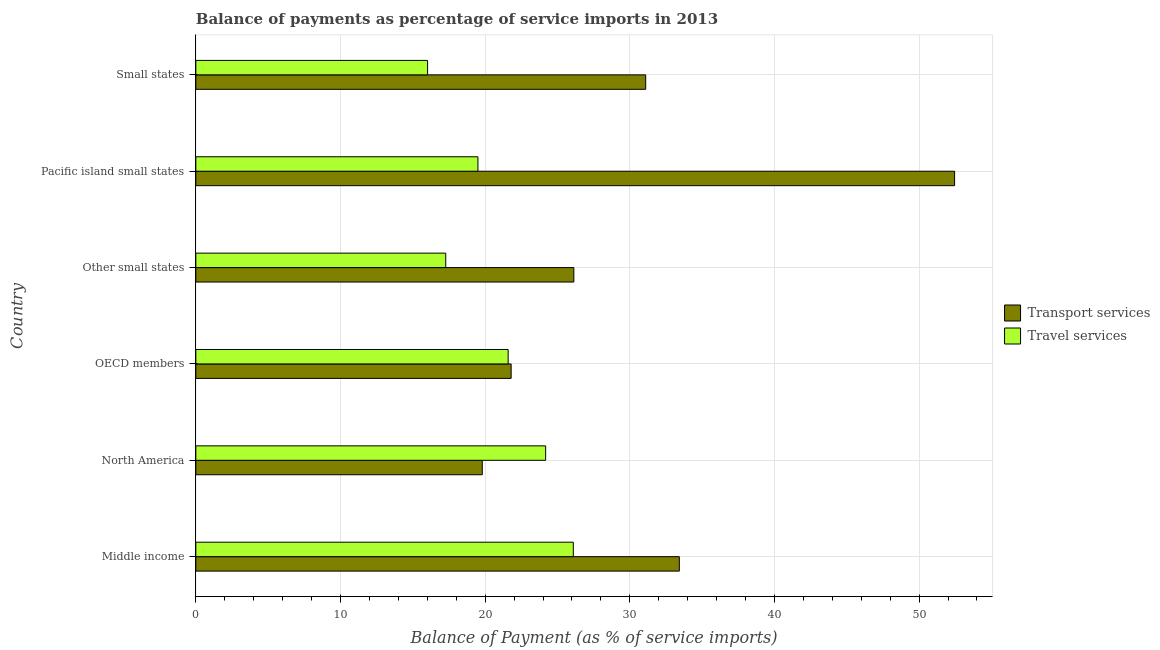How many different coloured bars are there?
Your answer should be compact. 2. How many groups of bars are there?
Your response must be concise. 6. Are the number of bars per tick equal to the number of legend labels?
Your answer should be very brief. Yes. Are the number of bars on each tick of the Y-axis equal?
Provide a succinct answer. Yes. How many bars are there on the 1st tick from the bottom?
Offer a terse response. 2. What is the label of the 3rd group of bars from the top?
Keep it short and to the point. Other small states. In how many cases, is the number of bars for a given country not equal to the number of legend labels?
Provide a succinct answer. 0. What is the balance of payments of travel services in Middle income?
Your answer should be very brief. 26.1. Across all countries, what is the maximum balance of payments of travel services?
Your answer should be very brief. 26.1. Across all countries, what is the minimum balance of payments of travel services?
Your answer should be very brief. 16.02. In which country was the balance of payments of transport services maximum?
Your response must be concise. Pacific island small states. In which country was the balance of payments of travel services minimum?
Make the answer very short. Small states. What is the total balance of payments of transport services in the graph?
Offer a very short reply. 184.71. What is the difference between the balance of payments of travel services in OECD members and that in Small states?
Keep it short and to the point. 5.57. What is the difference between the balance of payments of travel services in Middle income and the balance of payments of transport services in Other small states?
Your answer should be compact. -0.04. What is the average balance of payments of travel services per country?
Offer a terse response. 20.78. What is the difference between the balance of payments of transport services and balance of payments of travel services in Middle income?
Give a very brief answer. 7.33. In how many countries, is the balance of payments of travel services greater than 36 %?
Offer a terse response. 0. What is the ratio of the balance of payments of travel services in North America to that in Pacific island small states?
Make the answer very short. 1.24. Is the balance of payments of transport services in OECD members less than that in Pacific island small states?
Your answer should be compact. Yes. Is the difference between the balance of payments of travel services in OECD members and Small states greater than the difference between the balance of payments of transport services in OECD members and Small states?
Make the answer very short. Yes. What is the difference between the highest and the second highest balance of payments of travel services?
Your answer should be compact. 1.91. What is the difference between the highest and the lowest balance of payments of transport services?
Provide a short and direct response. 32.65. In how many countries, is the balance of payments of transport services greater than the average balance of payments of transport services taken over all countries?
Give a very brief answer. 3. Is the sum of the balance of payments of transport services in Middle income and Small states greater than the maximum balance of payments of travel services across all countries?
Ensure brevity in your answer.  Yes. What does the 2nd bar from the top in North America represents?
Ensure brevity in your answer.  Transport services. What does the 1st bar from the bottom in Small states represents?
Offer a terse response. Transport services. How many bars are there?
Offer a terse response. 12. Are the values on the major ticks of X-axis written in scientific E-notation?
Ensure brevity in your answer.  No. Does the graph contain any zero values?
Ensure brevity in your answer.  No. Does the graph contain grids?
Your answer should be very brief. Yes. Where does the legend appear in the graph?
Make the answer very short. Center right. How many legend labels are there?
Your answer should be compact. 2. What is the title of the graph?
Your answer should be compact. Balance of payments as percentage of service imports in 2013. What is the label or title of the X-axis?
Provide a succinct answer. Balance of Payment (as % of service imports). What is the Balance of Payment (as % of service imports) of Transport services in Middle income?
Offer a very short reply. 33.42. What is the Balance of Payment (as % of service imports) in Travel services in Middle income?
Your answer should be compact. 26.1. What is the Balance of Payment (as % of service imports) in Transport services in North America?
Offer a terse response. 19.8. What is the Balance of Payment (as % of service imports) in Travel services in North America?
Give a very brief answer. 24.18. What is the Balance of Payment (as % of service imports) of Transport services in OECD members?
Provide a short and direct response. 21.8. What is the Balance of Payment (as % of service imports) in Travel services in OECD members?
Provide a succinct answer. 21.59. What is the Balance of Payment (as % of service imports) in Transport services in Other small states?
Provide a short and direct response. 26.13. What is the Balance of Payment (as % of service imports) in Travel services in Other small states?
Provide a short and direct response. 17.28. What is the Balance of Payment (as % of service imports) of Transport services in Pacific island small states?
Make the answer very short. 52.45. What is the Balance of Payment (as % of service imports) of Travel services in Pacific island small states?
Offer a terse response. 19.5. What is the Balance of Payment (as % of service imports) in Transport services in Small states?
Keep it short and to the point. 31.1. What is the Balance of Payment (as % of service imports) of Travel services in Small states?
Offer a very short reply. 16.02. Across all countries, what is the maximum Balance of Payment (as % of service imports) in Transport services?
Ensure brevity in your answer.  52.45. Across all countries, what is the maximum Balance of Payment (as % of service imports) in Travel services?
Ensure brevity in your answer.  26.1. Across all countries, what is the minimum Balance of Payment (as % of service imports) of Transport services?
Offer a very short reply. 19.8. Across all countries, what is the minimum Balance of Payment (as % of service imports) in Travel services?
Offer a very short reply. 16.02. What is the total Balance of Payment (as % of service imports) of Transport services in the graph?
Offer a terse response. 184.71. What is the total Balance of Payment (as % of service imports) of Travel services in the graph?
Keep it short and to the point. 124.67. What is the difference between the Balance of Payment (as % of service imports) in Transport services in Middle income and that in North America?
Give a very brief answer. 13.62. What is the difference between the Balance of Payment (as % of service imports) of Travel services in Middle income and that in North America?
Your answer should be very brief. 1.91. What is the difference between the Balance of Payment (as % of service imports) of Transport services in Middle income and that in OECD members?
Offer a very short reply. 11.63. What is the difference between the Balance of Payment (as % of service imports) in Travel services in Middle income and that in OECD members?
Make the answer very short. 4.5. What is the difference between the Balance of Payment (as % of service imports) in Transport services in Middle income and that in Other small states?
Offer a very short reply. 7.29. What is the difference between the Balance of Payment (as % of service imports) of Travel services in Middle income and that in Other small states?
Offer a very short reply. 8.82. What is the difference between the Balance of Payment (as % of service imports) of Transport services in Middle income and that in Pacific island small states?
Offer a very short reply. -19.03. What is the difference between the Balance of Payment (as % of service imports) in Travel services in Middle income and that in Pacific island small states?
Provide a succinct answer. 6.59. What is the difference between the Balance of Payment (as % of service imports) of Transport services in Middle income and that in Small states?
Your response must be concise. 2.32. What is the difference between the Balance of Payment (as % of service imports) of Travel services in Middle income and that in Small states?
Keep it short and to the point. 10.07. What is the difference between the Balance of Payment (as % of service imports) of Transport services in North America and that in OECD members?
Offer a terse response. -2. What is the difference between the Balance of Payment (as % of service imports) in Travel services in North America and that in OECD members?
Provide a short and direct response. 2.59. What is the difference between the Balance of Payment (as % of service imports) of Transport services in North America and that in Other small states?
Offer a terse response. -6.33. What is the difference between the Balance of Payment (as % of service imports) in Travel services in North America and that in Other small states?
Your answer should be compact. 6.91. What is the difference between the Balance of Payment (as % of service imports) in Transport services in North America and that in Pacific island small states?
Provide a short and direct response. -32.65. What is the difference between the Balance of Payment (as % of service imports) of Travel services in North America and that in Pacific island small states?
Give a very brief answer. 4.68. What is the difference between the Balance of Payment (as % of service imports) of Transport services in North America and that in Small states?
Keep it short and to the point. -11.3. What is the difference between the Balance of Payment (as % of service imports) of Travel services in North America and that in Small states?
Give a very brief answer. 8.16. What is the difference between the Balance of Payment (as % of service imports) of Transport services in OECD members and that in Other small states?
Give a very brief answer. -4.34. What is the difference between the Balance of Payment (as % of service imports) in Travel services in OECD members and that in Other small states?
Offer a terse response. 4.31. What is the difference between the Balance of Payment (as % of service imports) of Transport services in OECD members and that in Pacific island small states?
Provide a succinct answer. -30.66. What is the difference between the Balance of Payment (as % of service imports) in Travel services in OECD members and that in Pacific island small states?
Your response must be concise. 2.09. What is the difference between the Balance of Payment (as % of service imports) of Transport services in OECD members and that in Small states?
Keep it short and to the point. -9.3. What is the difference between the Balance of Payment (as % of service imports) in Travel services in OECD members and that in Small states?
Your answer should be very brief. 5.57. What is the difference between the Balance of Payment (as % of service imports) of Transport services in Other small states and that in Pacific island small states?
Keep it short and to the point. -26.32. What is the difference between the Balance of Payment (as % of service imports) in Travel services in Other small states and that in Pacific island small states?
Your answer should be compact. -2.23. What is the difference between the Balance of Payment (as % of service imports) of Transport services in Other small states and that in Small states?
Give a very brief answer. -4.97. What is the difference between the Balance of Payment (as % of service imports) of Travel services in Other small states and that in Small states?
Provide a succinct answer. 1.25. What is the difference between the Balance of Payment (as % of service imports) of Transport services in Pacific island small states and that in Small states?
Your answer should be very brief. 21.35. What is the difference between the Balance of Payment (as % of service imports) in Travel services in Pacific island small states and that in Small states?
Make the answer very short. 3.48. What is the difference between the Balance of Payment (as % of service imports) of Transport services in Middle income and the Balance of Payment (as % of service imports) of Travel services in North America?
Make the answer very short. 9.24. What is the difference between the Balance of Payment (as % of service imports) in Transport services in Middle income and the Balance of Payment (as % of service imports) in Travel services in OECD members?
Give a very brief answer. 11.83. What is the difference between the Balance of Payment (as % of service imports) of Transport services in Middle income and the Balance of Payment (as % of service imports) of Travel services in Other small states?
Offer a terse response. 16.15. What is the difference between the Balance of Payment (as % of service imports) in Transport services in Middle income and the Balance of Payment (as % of service imports) in Travel services in Pacific island small states?
Your response must be concise. 13.92. What is the difference between the Balance of Payment (as % of service imports) of Transport services in Middle income and the Balance of Payment (as % of service imports) of Travel services in Small states?
Your response must be concise. 17.4. What is the difference between the Balance of Payment (as % of service imports) of Transport services in North America and the Balance of Payment (as % of service imports) of Travel services in OECD members?
Provide a short and direct response. -1.79. What is the difference between the Balance of Payment (as % of service imports) of Transport services in North America and the Balance of Payment (as % of service imports) of Travel services in Other small states?
Your response must be concise. 2.53. What is the difference between the Balance of Payment (as % of service imports) of Transport services in North America and the Balance of Payment (as % of service imports) of Travel services in Pacific island small states?
Provide a short and direct response. 0.3. What is the difference between the Balance of Payment (as % of service imports) in Transport services in North America and the Balance of Payment (as % of service imports) in Travel services in Small states?
Make the answer very short. 3.78. What is the difference between the Balance of Payment (as % of service imports) in Transport services in OECD members and the Balance of Payment (as % of service imports) in Travel services in Other small states?
Your response must be concise. 4.52. What is the difference between the Balance of Payment (as % of service imports) in Transport services in OECD members and the Balance of Payment (as % of service imports) in Travel services in Pacific island small states?
Your response must be concise. 2.3. What is the difference between the Balance of Payment (as % of service imports) of Transport services in OECD members and the Balance of Payment (as % of service imports) of Travel services in Small states?
Provide a short and direct response. 5.78. What is the difference between the Balance of Payment (as % of service imports) of Transport services in Other small states and the Balance of Payment (as % of service imports) of Travel services in Pacific island small states?
Offer a terse response. 6.63. What is the difference between the Balance of Payment (as % of service imports) in Transport services in Other small states and the Balance of Payment (as % of service imports) in Travel services in Small states?
Ensure brevity in your answer.  10.11. What is the difference between the Balance of Payment (as % of service imports) of Transport services in Pacific island small states and the Balance of Payment (as % of service imports) of Travel services in Small states?
Your answer should be compact. 36.43. What is the average Balance of Payment (as % of service imports) of Transport services per country?
Ensure brevity in your answer.  30.79. What is the average Balance of Payment (as % of service imports) in Travel services per country?
Keep it short and to the point. 20.78. What is the difference between the Balance of Payment (as % of service imports) of Transport services and Balance of Payment (as % of service imports) of Travel services in Middle income?
Provide a short and direct response. 7.33. What is the difference between the Balance of Payment (as % of service imports) of Transport services and Balance of Payment (as % of service imports) of Travel services in North America?
Offer a terse response. -4.38. What is the difference between the Balance of Payment (as % of service imports) in Transport services and Balance of Payment (as % of service imports) in Travel services in OECD members?
Provide a succinct answer. 0.21. What is the difference between the Balance of Payment (as % of service imports) in Transport services and Balance of Payment (as % of service imports) in Travel services in Other small states?
Offer a terse response. 8.86. What is the difference between the Balance of Payment (as % of service imports) of Transport services and Balance of Payment (as % of service imports) of Travel services in Pacific island small states?
Make the answer very short. 32.95. What is the difference between the Balance of Payment (as % of service imports) in Transport services and Balance of Payment (as % of service imports) in Travel services in Small states?
Your response must be concise. 15.08. What is the ratio of the Balance of Payment (as % of service imports) of Transport services in Middle income to that in North America?
Your answer should be compact. 1.69. What is the ratio of the Balance of Payment (as % of service imports) of Travel services in Middle income to that in North America?
Make the answer very short. 1.08. What is the ratio of the Balance of Payment (as % of service imports) of Transport services in Middle income to that in OECD members?
Keep it short and to the point. 1.53. What is the ratio of the Balance of Payment (as % of service imports) in Travel services in Middle income to that in OECD members?
Your response must be concise. 1.21. What is the ratio of the Balance of Payment (as % of service imports) of Transport services in Middle income to that in Other small states?
Offer a terse response. 1.28. What is the ratio of the Balance of Payment (as % of service imports) of Travel services in Middle income to that in Other small states?
Offer a very short reply. 1.51. What is the ratio of the Balance of Payment (as % of service imports) of Transport services in Middle income to that in Pacific island small states?
Your answer should be compact. 0.64. What is the ratio of the Balance of Payment (as % of service imports) of Travel services in Middle income to that in Pacific island small states?
Give a very brief answer. 1.34. What is the ratio of the Balance of Payment (as % of service imports) in Transport services in Middle income to that in Small states?
Make the answer very short. 1.07. What is the ratio of the Balance of Payment (as % of service imports) of Travel services in Middle income to that in Small states?
Your response must be concise. 1.63. What is the ratio of the Balance of Payment (as % of service imports) of Transport services in North America to that in OECD members?
Your response must be concise. 0.91. What is the ratio of the Balance of Payment (as % of service imports) of Travel services in North America to that in OECD members?
Keep it short and to the point. 1.12. What is the ratio of the Balance of Payment (as % of service imports) of Transport services in North America to that in Other small states?
Give a very brief answer. 0.76. What is the ratio of the Balance of Payment (as % of service imports) in Travel services in North America to that in Other small states?
Offer a terse response. 1.4. What is the ratio of the Balance of Payment (as % of service imports) of Transport services in North America to that in Pacific island small states?
Provide a short and direct response. 0.38. What is the ratio of the Balance of Payment (as % of service imports) of Travel services in North America to that in Pacific island small states?
Provide a succinct answer. 1.24. What is the ratio of the Balance of Payment (as % of service imports) in Transport services in North America to that in Small states?
Your answer should be compact. 0.64. What is the ratio of the Balance of Payment (as % of service imports) of Travel services in North America to that in Small states?
Keep it short and to the point. 1.51. What is the ratio of the Balance of Payment (as % of service imports) of Transport services in OECD members to that in Other small states?
Offer a terse response. 0.83. What is the ratio of the Balance of Payment (as % of service imports) in Travel services in OECD members to that in Other small states?
Provide a short and direct response. 1.25. What is the ratio of the Balance of Payment (as % of service imports) in Transport services in OECD members to that in Pacific island small states?
Your response must be concise. 0.42. What is the ratio of the Balance of Payment (as % of service imports) of Travel services in OECD members to that in Pacific island small states?
Your answer should be compact. 1.11. What is the ratio of the Balance of Payment (as % of service imports) of Transport services in OECD members to that in Small states?
Ensure brevity in your answer.  0.7. What is the ratio of the Balance of Payment (as % of service imports) of Travel services in OECD members to that in Small states?
Offer a very short reply. 1.35. What is the ratio of the Balance of Payment (as % of service imports) in Transport services in Other small states to that in Pacific island small states?
Provide a short and direct response. 0.5. What is the ratio of the Balance of Payment (as % of service imports) of Travel services in Other small states to that in Pacific island small states?
Your answer should be compact. 0.89. What is the ratio of the Balance of Payment (as % of service imports) of Transport services in Other small states to that in Small states?
Give a very brief answer. 0.84. What is the ratio of the Balance of Payment (as % of service imports) in Travel services in Other small states to that in Small states?
Your answer should be very brief. 1.08. What is the ratio of the Balance of Payment (as % of service imports) in Transport services in Pacific island small states to that in Small states?
Make the answer very short. 1.69. What is the ratio of the Balance of Payment (as % of service imports) of Travel services in Pacific island small states to that in Small states?
Your answer should be very brief. 1.22. What is the difference between the highest and the second highest Balance of Payment (as % of service imports) of Transport services?
Provide a succinct answer. 19.03. What is the difference between the highest and the second highest Balance of Payment (as % of service imports) in Travel services?
Keep it short and to the point. 1.91. What is the difference between the highest and the lowest Balance of Payment (as % of service imports) in Transport services?
Offer a terse response. 32.65. What is the difference between the highest and the lowest Balance of Payment (as % of service imports) of Travel services?
Give a very brief answer. 10.07. 